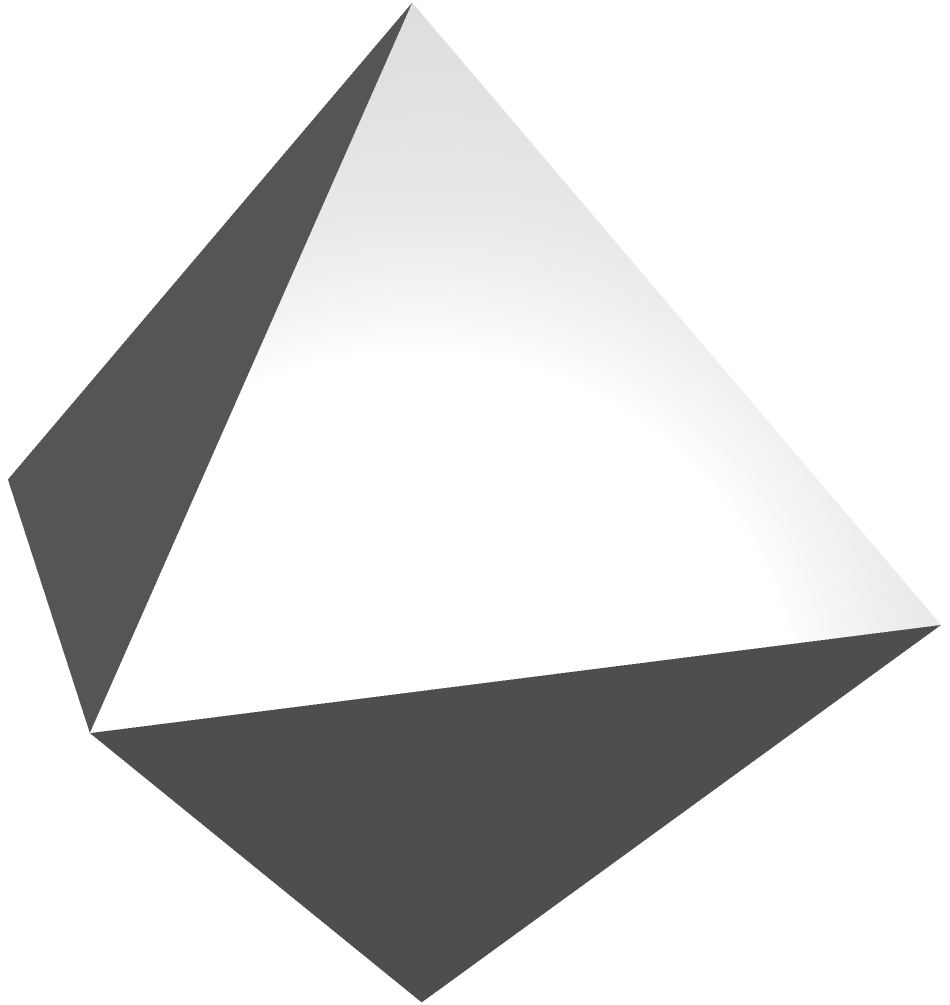Consider a regular octahedron with edge length $a$. If the surface area of this octahedron represents the total sum of virtues in a moral framework, and each face symbolizes a distinct virtue, how would you interpret the relationship between the surface area formula $A = 2\sqrt{3}a^2$ and the concept of virtue ethics? Additionally, how might the symmetry of the octahedron relate to the balance of virtues in moral philosophy? 1. Surface area formula: The surface area of a regular octahedron is given by $A = 2\sqrt{3}a^2$, where $a$ is the edge length.

2. Interpretation of the formula:
   a) The factor 2 represents the duality of virtues (e.g., courage balanced by prudence).
   b) $\sqrt{3}$ symbolizes the interconnectedness of virtues in a triangular relationship.
   c) $a^2$ represents the "strength" or "magnitude" of each virtue.

3. Symmetry and balance:
   a) The octahedron has 8 faces, each an equilateral triangle, symbolizing equality among virtues.
   b) The perfect symmetry represents the ideal balance of virtues in a moral framework.
   c) Each vertex connects 4 faces, suggesting that virtues are interconnected and mutually reinforcing.

4. Ethical implications:
   a) The total surface area (sum of virtues) increases quadratically with the edge length, implying that developing one virtue strengthens the entire moral framework.
   b) The regularity of the octahedron suggests that all virtues are equally important and should be developed in harmony.
   c) The three-dimensional nature of the octahedron represents the complexity and depth of moral character.

5. Relation to virtue ethics:
   a) Virtue ethics focuses on the development of moral character rather than rules or consequences.
   b) The octahedron model aligns with this by emphasizing the interconnectedness and balance of virtues.
   c) The geometric representation provides a visual and mathematical metaphor for the holistic nature of virtue ethics.
Answer: The octahedron's surface area formula represents the sum of virtues, with symmetry symbolizing their balance and interconnectedness in virtue ethics. 